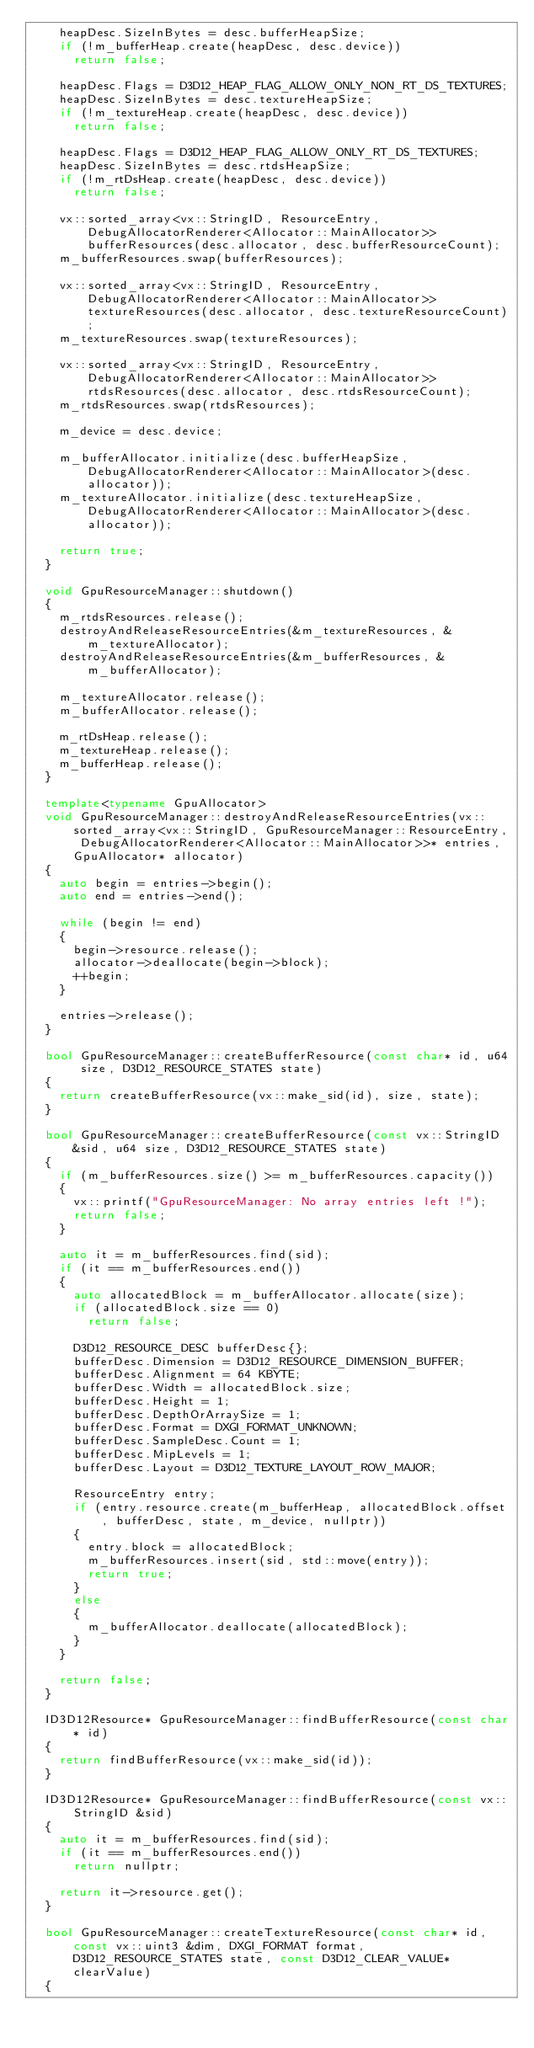Convert code to text. <code><loc_0><loc_0><loc_500><loc_500><_C++_>		heapDesc.SizeInBytes = desc.bufferHeapSize;
		if (!m_bufferHeap.create(heapDesc, desc.device))
			return false;

		heapDesc.Flags = D3D12_HEAP_FLAG_ALLOW_ONLY_NON_RT_DS_TEXTURES;
		heapDesc.SizeInBytes = desc.textureHeapSize;
		if (!m_textureHeap.create(heapDesc, desc.device))
			return false;

		heapDesc.Flags = D3D12_HEAP_FLAG_ALLOW_ONLY_RT_DS_TEXTURES;
		heapDesc.SizeInBytes = desc.rtdsHeapSize;
		if (!m_rtDsHeap.create(heapDesc, desc.device))
			return false;

		vx::sorted_array<vx::StringID, ResourceEntry, DebugAllocatorRenderer<Allocator::MainAllocator>> bufferResources(desc.allocator, desc.bufferResourceCount);
		m_bufferResources.swap(bufferResources);

		vx::sorted_array<vx::StringID, ResourceEntry, DebugAllocatorRenderer<Allocator::MainAllocator>> textureResources(desc.allocator, desc.textureResourceCount);
		m_textureResources.swap(textureResources);

		vx::sorted_array<vx::StringID, ResourceEntry, DebugAllocatorRenderer<Allocator::MainAllocator>> rtdsResources(desc.allocator, desc.rtdsResourceCount);
		m_rtdsResources.swap(rtdsResources);

		m_device = desc.device;

		m_bufferAllocator.initialize(desc.bufferHeapSize, DebugAllocatorRenderer<Allocator::MainAllocator>(desc.allocator));
		m_textureAllocator.initialize(desc.textureHeapSize, DebugAllocatorRenderer<Allocator::MainAllocator>(desc.allocator));

		return true;
	}

	void GpuResourceManager::shutdown()
	{
		m_rtdsResources.release();
		destroyAndReleaseResourceEntries(&m_textureResources, &m_textureAllocator);
		destroyAndReleaseResourceEntries(&m_bufferResources, &m_bufferAllocator);

		m_textureAllocator.release();
		m_bufferAllocator.release();

		m_rtDsHeap.release();
		m_textureHeap.release();
		m_bufferHeap.release();
	}

	template<typename GpuAllocator>
	void GpuResourceManager::destroyAndReleaseResourceEntries(vx::sorted_array<vx::StringID, GpuResourceManager::ResourceEntry, DebugAllocatorRenderer<Allocator::MainAllocator>>* entries, GpuAllocator* allocator)
	{
		auto begin = entries->begin();
		auto end = entries->end();

		while (begin != end)
		{
			begin->resource.release();
			allocator->deallocate(begin->block);
			++begin;
		}

		entries->release();
	}

	bool GpuResourceManager::createBufferResource(const char* id, u64 size, D3D12_RESOURCE_STATES state)
	{
		return createBufferResource(vx::make_sid(id), size, state);
	}

	bool GpuResourceManager::createBufferResource(const vx::StringID &sid, u64 size, D3D12_RESOURCE_STATES state)
	{
		if (m_bufferResources.size() >= m_bufferResources.capacity())
		{
			vx::printf("GpuResourceManager: No array entries left !");
			return false;
		}

		auto it = m_bufferResources.find(sid);
		if (it == m_bufferResources.end())
		{
			auto allocatedBlock = m_bufferAllocator.allocate(size);
			if (allocatedBlock.size == 0)
				return false;

			D3D12_RESOURCE_DESC bufferDesc{};
			bufferDesc.Dimension = D3D12_RESOURCE_DIMENSION_BUFFER;
			bufferDesc.Alignment = 64 KBYTE;
			bufferDesc.Width = allocatedBlock.size;
			bufferDesc.Height = 1;
			bufferDesc.DepthOrArraySize = 1;
			bufferDesc.Format = DXGI_FORMAT_UNKNOWN;
			bufferDesc.SampleDesc.Count = 1;
			bufferDesc.MipLevels = 1;
			bufferDesc.Layout = D3D12_TEXTURE_LAYOUT_ROW_MAJOR;

			ResourceEntry entry;
			if (entry.resource.create(m_bufferHeap, allocatedBlock.offset, bufferDesc, state, m_device, nullptr))
			{
				entry.block = allocatedBlock;
				m_bufferResources.insert(sid, std::move(entry));
				return true;
			}
			else
			{
				m_bufferAllocator.deallocate(allocatedBlock);
			}
		}

		return false;
	}

	ID3D12Resource* GpuResourceManager::findBufferResource(const char* id)
	{
		return findBufferResource(vx::make_sid(id));
	}

	ID3D12Resource* GpuResourceManager::findBufferResource(const vx::StringID &sid)
	{
		auto it = m_bufferResources.find(sid);
		if (it == m_bufferResources.end())
			return nullptr;

		return it->resource.get();
	}

	bool GpuResourceManager::createTextureResource(const char* id, const vx::uint3 &dim, DXGI_FORMAT format, D3D12_RESOURCE_STATES state, const D3D12_CLEAR_VALUE* clearValue)
	{</code> 